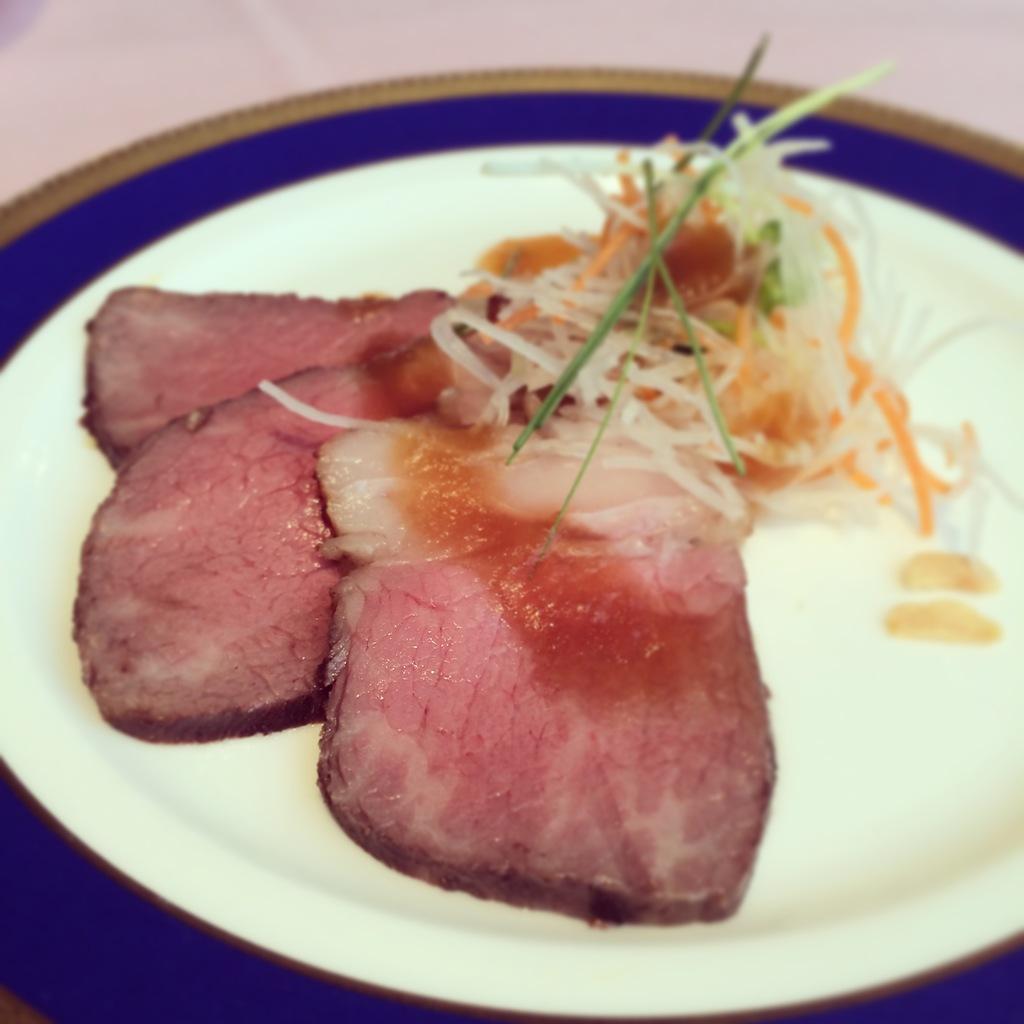How would you summarize this image in a sentence or two? In this image we can see cooked meat and food item in the plate. 